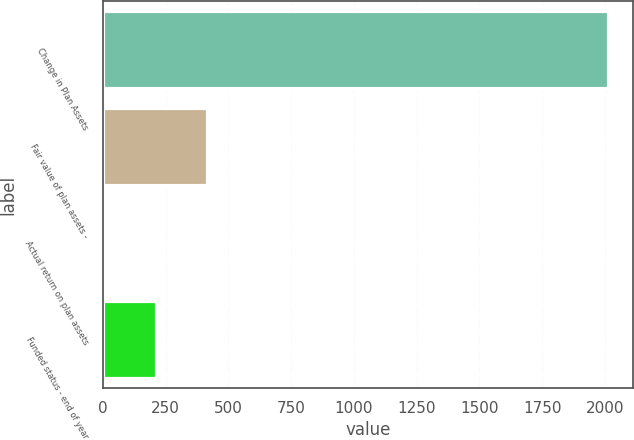Convert chart. <chart><loc_0><loc_0><loc_500><loc_500><bar_chart><fcel>Change in Plan Assets<fcel>Fair value of plan assets -<fcel>Actual return on plan assets<fcel>Funded status - end of year<nl><fcel>2013<fcel>413<fcel>13<fcel>213<nl></chart> 